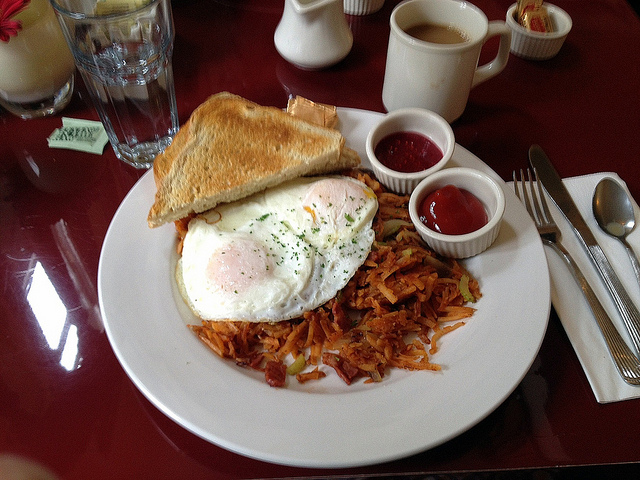How could this meal be made more nutritious without altering its traditional appeal? To enhance the nutritional value of this traditional breakfast while maintaining its appeal, one could consider using whole wheat or multigrain toast to increase fiber content. Additionally, incorporating a side of fresh fruits like berries or a sliced orange could add vitamins and freshness to the meal, complementing the existing components without overshadowing them. 